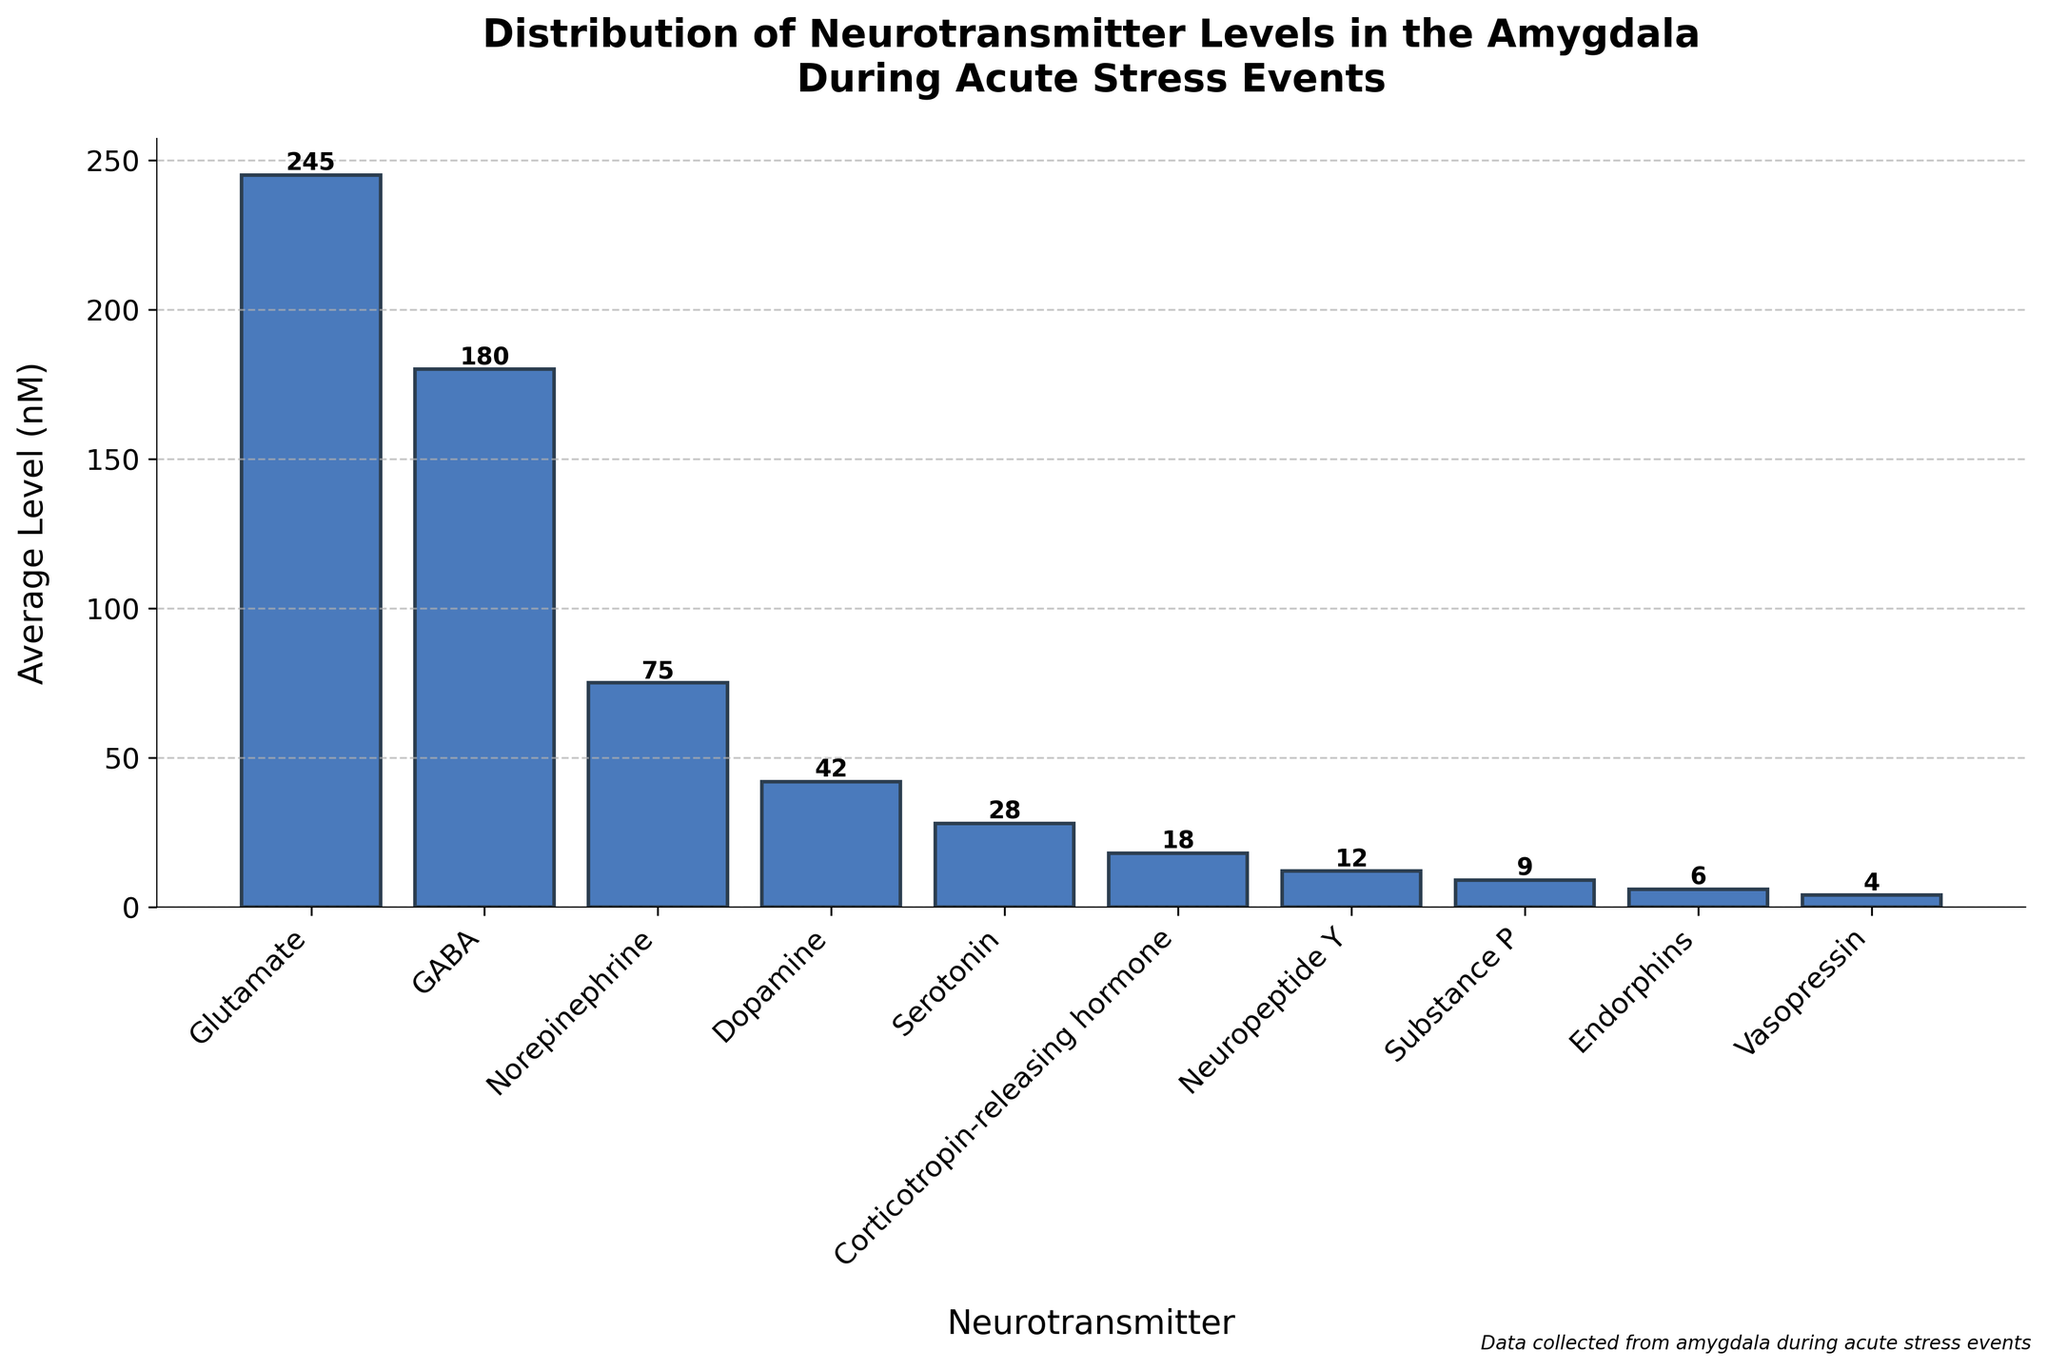What neurotransmitter has the highest average level in the amygdala during acute stress events? By observing the heights of the bars in the bar chart, the tallest bar corresponds to Glutamate, indicating it has the highest average level.
Answer: Glutamate What is the combined average level of Norepinephrine and Dopamine? Norepinephrine has an average level of 75 nM, and Dopamine has an average level of 42 nM. Adding these together gives 75 + 42.
Answer: 117 Which neurotransmitter has a higher average level: GABA or Serotonin? GABA has an average level of 180 nM, and Serotonin has an average level of 28 nM. Comparing these values, GABA is higher.
Answer: GABA By how much does the average level of Glutamate exceed that of Corticotropin-releasing hormone? The average level of Glutamate is 245 nM, and Corticotropin-releasing hormone is 18 nM. The difference is 245 - 18.
Answer: 227 What is the median average level among all the neurotransmitters listed? To find the median, list the average levels in ascending order: 4, 6, 9, 12, 18, 28, 42, 75, 180, 245. The median is the average of the 5th and 6th values: (18 + 28)/2.
Answer: 23 Are there more neurotransmitters with average levels above 100 nM or below 100 nM? Count the neurotransmitters with average levels above 100 nM (Glutamate, GABA) and those below 100 nM (Norepinephrine, Dopamine, Serotonin, Corticotropin-releasing hormone, Neuropeptide Y, Substance P, Endorphins, Vasopressin).
Answer: Below 100 nM What is the average level of the neurotransmitter with the third-lowest concentration? Order the neurotransmitters by their average levels: Vasopressin (4), Endorphins (6), Substance P (9). The third-lowest is Substance P.
Answer: 9 What are the neurotransmitters with average levels less than 10 nM? Looking at the bar lengths, those that fall below the 10 nM mark are Substance P (9), Endorphins (6), and Vasopressin (4).
Answer: Substance P, Endorphins, Vasopressin How does the average level of Neuropeptide Y compare to that of Dopamine? Neuropeptide Y has an average level of 12 nM, and Dopamine has an average level of 42 nM. Dopamine's level is higher than Neuropeptide Y's.
Answer: Lower Which neurotransmitter with an average level below 50 nM has the highest concentration? Among the neurotransmitters below 50 nM, Dopamine has the highest average level, which is 42 nM.
Answer: Dopamine 